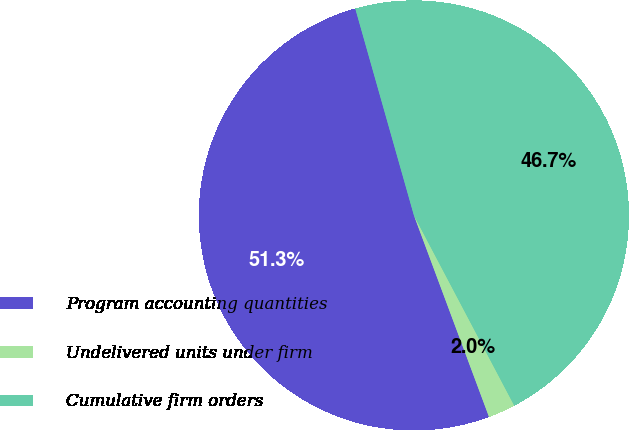Convert chart to OTSL. <chart><loc_0><loc_0><loc_500><loc_500><pie_chart><fcel>Program accounting quantities<fcel>Undelivered units under firm<fcel>Cumulative firm orders<nl><fcel>51.28%<fcel>2.05%<fcel>46.67%<nl></chart> 